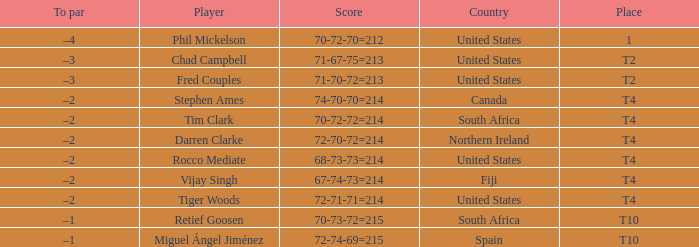What country does Rocco Mediate play for? United States. 